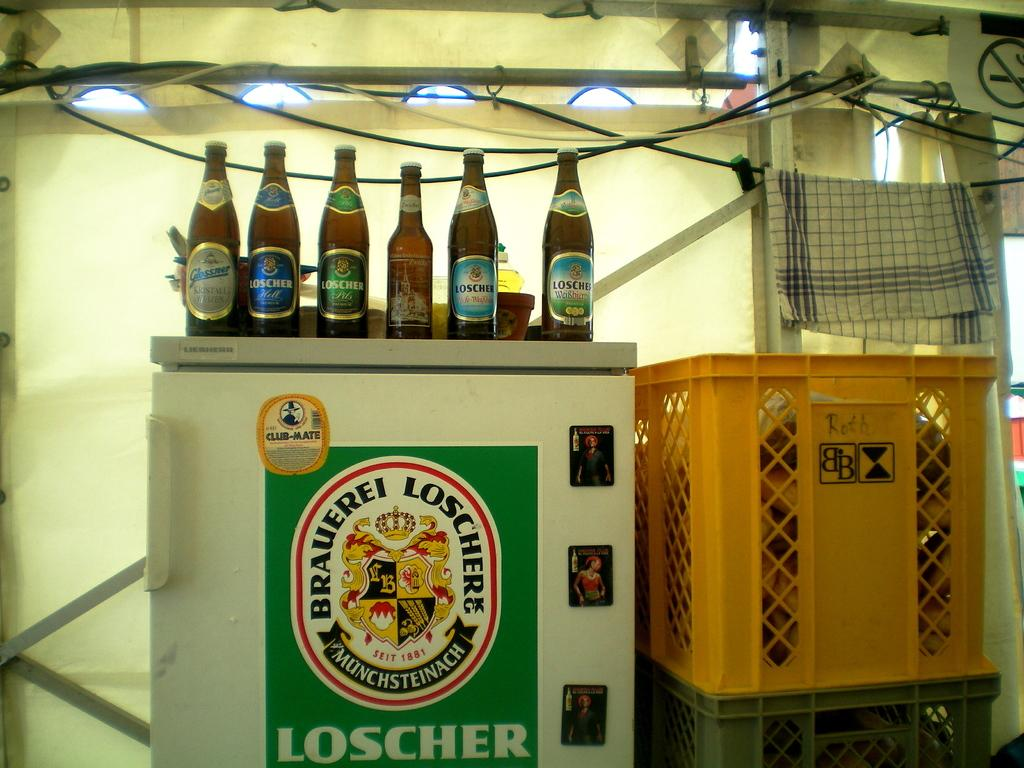Provide a one-sentence caption for the provided image. Beer bottle with a blue label for Loscher next to other beers. 